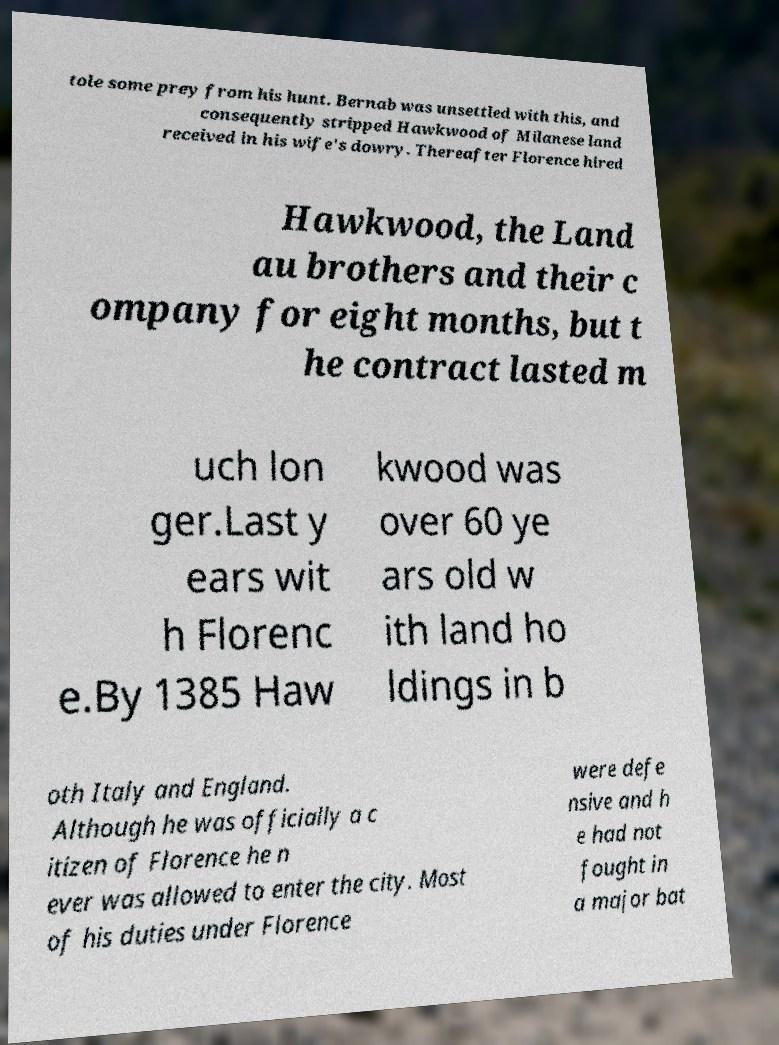Could you extract and type out the text from this image? tole some prey from his hunt. Bernab was unsettled with this, and consequently stripped Hawkwood of Milanese land received in his wife's dowry. Thereafter Florence hired Hawkwood, the Land au brothers and their c ompany for eight months, but t he contract lasted m uch lon ger.Last y ears wit h Florenc e.By 1385 Haw kwood was over 60 ye ars old w ith land ho ldings in b oth Italy and England. Although he was officially a c itizen of Florence he n ever was allowed to enter the city. Most of his duties under Florence were defe nsive and h e had not fought in a major bat 